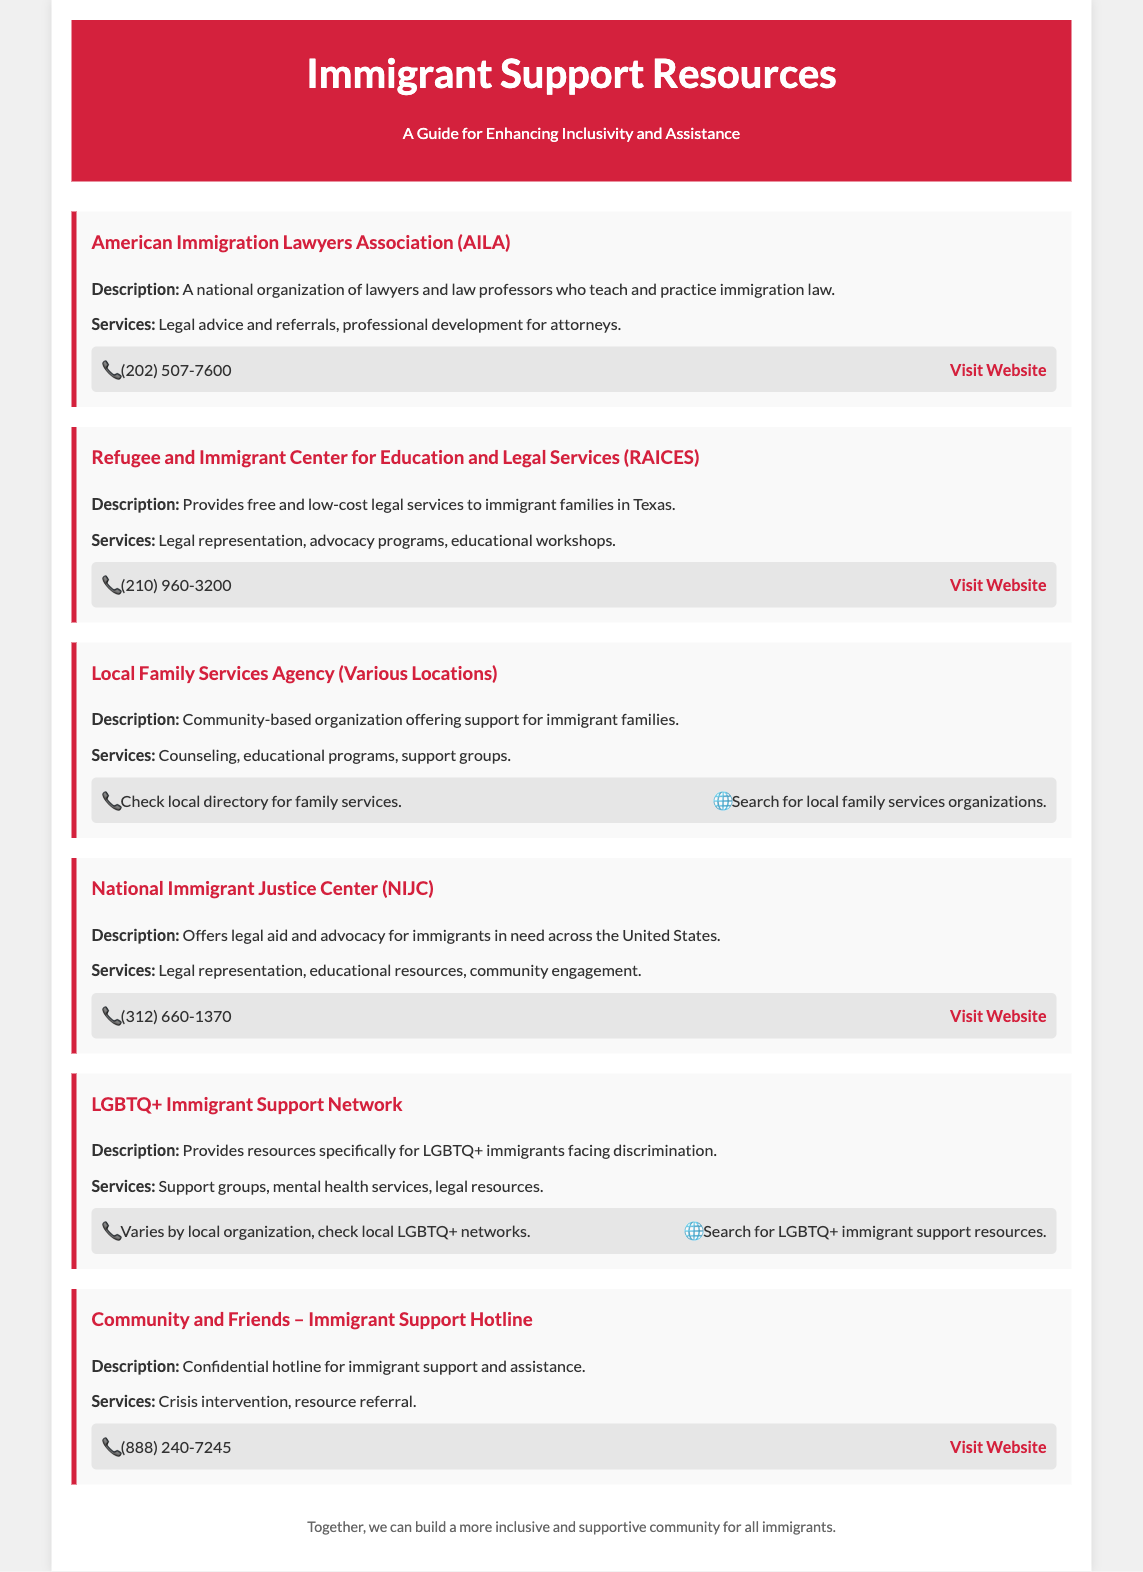What is the phone number for AILA? The phone number for AILA is provided under their contact information in the document.
Answer: (202) 507-7600 What services does RAICES offer? The services offered by RAICES are listed in the description section of their entry in the document.
Answer: Legal representation, advocacy programs, educational workshops What is the main focus of the LGBTQ+ Immigrant Support Network? The main focus of the LGBTQ+ Immigrant Support Network is described in its entry in the document.
Answer: Resources specifically for LGBTQ+ immigrants facing discrimination How can I reach the Community and Friends hotline? The contact information for the Community and Friends hotline is available in the document.
Answer: (888) 240-7245 What organization provides legal aid for immigrants across the United States? The organization that offers legal aid for immigrants as mentioned in the document.
Answer: National Immigrant Justice Center (NIJC) What is the description of the Local Family Services Agency? The description for the Local Family Services Agency is included in its section in the document.
Answer: Community-based organization offering support for immigrant families What educational services does NIJC provide? The educational services by NIJC are listed in their services section in the document.
Answer: Educational resources How can someone find local family services? The method to find local family services is indicated in the Local Family Services Agency entry.
Answer: Check local directory for family services 